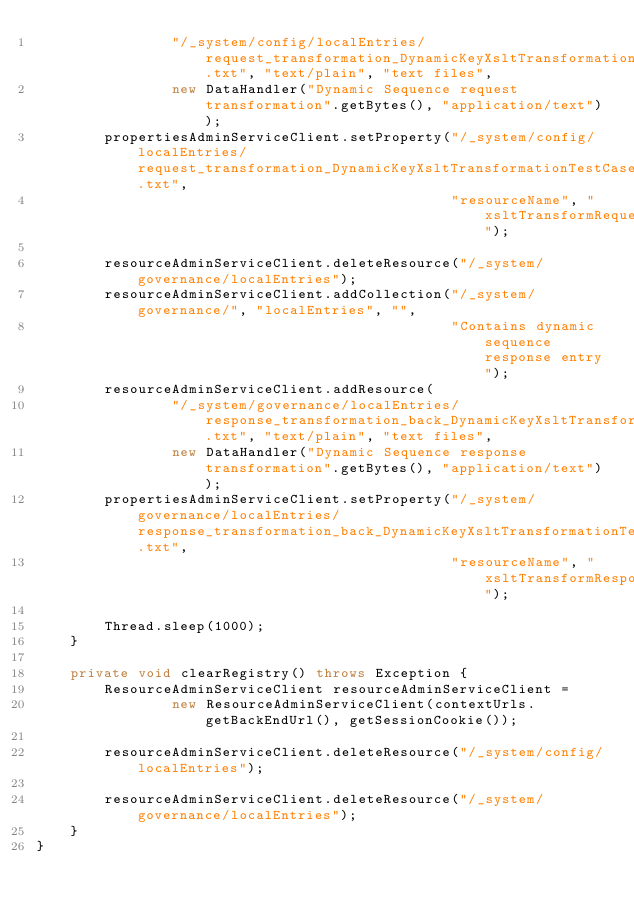<code> <loc_0><loc_0><loc_500><loc_500><_Java_>                "/_system/config/localEntries/request_transformation_DynamicKeyXsltTransformationTestCase.txt", "text/plain", "text files",
                new DataHandler("Dynamic Sequence request transformation".getBytes(), "application/text"));
        propertiesAdminServiceClient.setProperty("/_system/config/localEntries/request_transformation_DynamicKeyXsltTransformationTestCase.txt",
                                                 "resourceName", "xsltTransformRequest");

        resourceAdminServiceClient.deleteResource("/_system/governance/localEntries");
        resourceAdminServiceClient.addCollection("/_system/governance/", "localEntries", "",
                                                 "Contains dynamic sequence response entry");
        resourceAdminServiceClient.addResource(
                "/_system/governance/localEntries/response_transformation_back_DynamicKeyXsltTransformationTestCase.txt", "text/plain", "text files",
                new DataHandler("Dynamic Sequence response transformation".getBytes(), "application/text"));
        propertiesAdminServiceClient.setProperty("/_system/governance/localEntries/response_transformation_back_DynamicKeyXsltTransformationTestCase.txt",
                                                 "resourceName", "xsltTransformResponse");

        Thread.sleep(1000);
    }

    private void clearRegistry() throws Exception {
        ResourceAdminServiceClient resourceAdminServiceClient =
                new ResourceAdminServiceClient(contextUrls.getBackEndUrl(), getSessionCookie());

        resourceAdminServiceClient.deleteResource("/_system/config/localEntries");

        resourceAdminServiceClient.deleteResource("/_system/governance/localEntries");
    }
}
</code> 